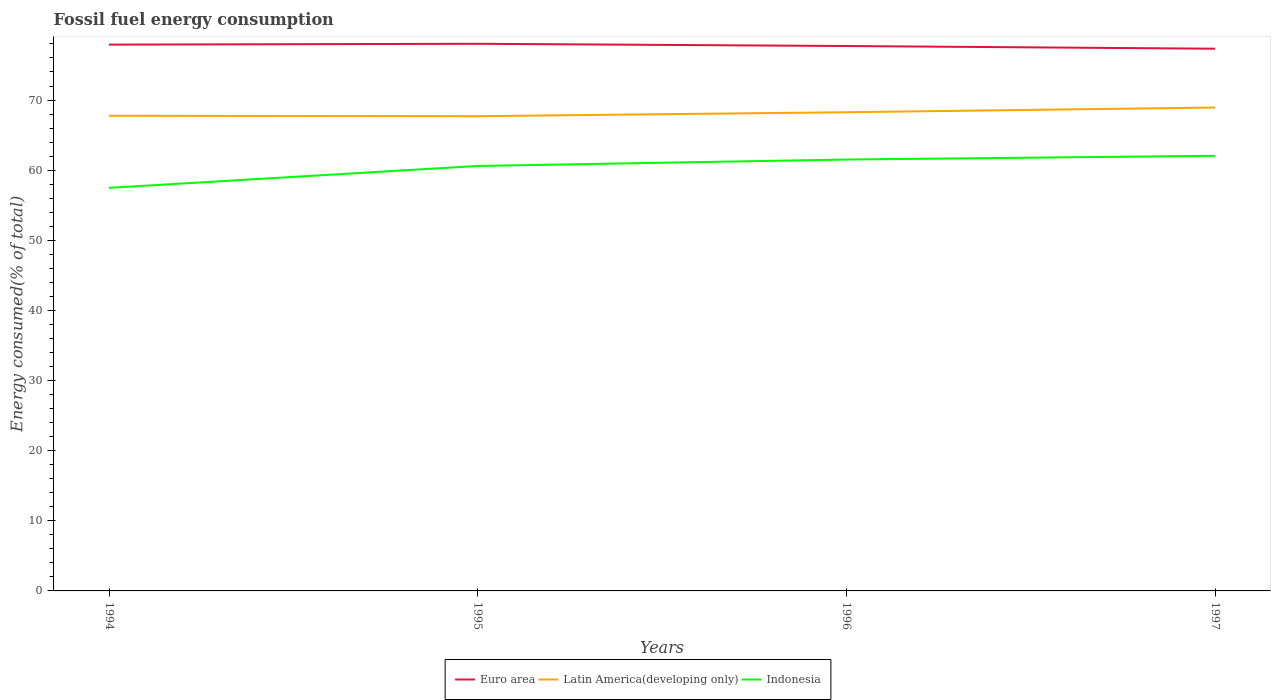Does the line corresponding to Latin America(developing only) intersect with the line corresponding to Indonesia?
Give a very brief answer. No. Across all years, what is the maximum percentage of energy consumed in Latin America(developing only)?
Provide a succinct answer. 67.7. In which year was the percentage of energy consumed in Latin America(developing only) maximum?
Make the answer very short. 1995. What is the total percentage of energy consumed in Indonesia in the graph?
Give a very brief answer. -0.53. What is the difference between the highest and the second highest percentage of energy consumed in Latin America(developing only)?
Offer a very short reply. 1.23. What is the difference between the highest and the lowest percentage of energy consumed in Latin America(developing only)?
Offer a terse response. 2. Is the percentage of energy consumed in Latin America(developing only) strictly greater than the percentage of energy consumed in Euro area over the years?
Provide a short and direct response. Yes. How many lines are there?
Your answer should be very brief. 3. Does the graph contain grids?
Your response must be concise. No. Where does the legend appear in the graph?
Offer a very short reply. Bottom center. How many legend labels are there?
Your answer should be compact. 3. How are the legend labels stacked?
Offer a terse response. Horizontal. What is the title of the graph?
Provide a short and direct response. Fossil fuel energy consumption. What is the label or title of the X-axis?
Your response must be concise. Years. What is the label or title of the Y-axis?
Keep it short and to the point. Energy consumed(% of total). What is the Energy consumed(% of total) of Euro area in 1994?
Make the answer very short. 77.9. What is the Energy consumed(% of total) in Latin America(developing only) in 1994?
Make the answer very short. 67.76. What is the Energy consumed(% of total) in Indonesia in 1994?
Give a very brief answer. 57.48. What is the Energy consumed(% of total) of Euro area in 1995?
Ensure brevity in your answer.  78.02. What is the Energy consumed(% of total) in Latin America(developing only) in 1995?
Your answer should be very brief. 67.7. What is the Energy consumed(% of total) in Indonesia in 1995?
Give a very brief answer. 60.6. What is the Energy consumed(% of total) of Euro area in 1996?
Your response must be concise. 77.7. What is the Energy consumed(% of total) of Latin America(developing only) in 1996?
Offer a terse response. 68.26. What is the Energy consumed(% of total) in Indonesia in 1996?
Your answer should be very brief. 61.51. What is the Energy consumed(% of total) in Euro area in 1997?
Make the answer very short. 77.32. What is the Energy consumed(% of total) of Latin America(developing only) in 1997?
Offer a very short reply. 68.93. What is the Energy consumed(% of total) of Indonesia in 1997?
Keep it short and to the point. 62.05. Across all years, what is the maximum Energy consumed(% of total) of Euro area?
Ensure brevity in your answer.  78.02. Across all years, what is the maximum Energy consumed(% of total) of Latin America(developing only)?
Offer a very short reply. 68.93. Across all years, what is the maximum Energy consumed(% of total) of Indonesia?
Offer a terse response. 62.05. Across all years, what is the minimum Energy consumed(% of total) in Euro area?
Offer a very short reply. 77.32. Across all years, what is the minimum Energy consumed(% of total) in Latin America(developing only)?
Give a very brief answer. 67.7. Across all years, what is the minimum Energy consumed(% of total) of Indonesia?
Ensure brevity in your answer.  57.48. What is the total Energy consumed(% of total) in Euro area in the graph?
Offer a very short reply. 310.95. What is the total Energy consumed(% of total) of Latin America(developing only) in the graph?
Keep it short and to the point. 272.64. What is the total Energy consumed(% of total) of Indonesia in the graph?
Ensure brevity in your answer.  241.64. What is the difference between the Energy consumed(% of total) in Euro area in 1994 and that in 1995?
Offer a very short reply. -0.12. What is the difference between the Energy consumed(% of total) of Latin America(developing only) in 1994 and that in 1995?
Give a very brief answer. 0.06. What is the difference between the Energy consumed(% of total) in Indonesia in 1994 and that in 1995?
Offer a terse response. -3.12. What is the difference between the Energy consumed(% of total) of Euro area in 1994 and that in 1996?
Ensure brevity in your answer.  0.2. What is the difference between the Energy consumed(% of total) of Latin America(developing only) in 1994 and that in 1996?
Your response must be concise. -0.5. What is the difference between the Energy consumed(% of total) of Indonesia in 1994 and that in 1996?
Provide a short and direct response. -4.04. What is the difference between the Energy consumed(% of total) in Euro area in 1994 and that in 1997?
Make the answer very short. 0.58. What is the difference between the Energy consumed(% of total) of Latin America(developing only) in 1994 and that in 1997?
Provide a succinct answer. -1.18. What is the difference between the Energy consumed(% of total) in Indonesia in 1994 and that in 1997?
Give a very brief answer. -4.57. What is the difference between the Energy consumed(% of total) of Euro area in 1995 and that in 1996?
Your answer should be very brief. 0.32. What is the difference between the Energy consumed(% of total) in Latin America(developing only) in 1995 and that in 1996?
Give a very brief answer. -0.56. What is the difference between the Energy consumed(% of total) of Indonesia in 1995 and that in 1996?
Offer a very short reply. -0.92. What is the difference between the Energy consumed(% of total) of Euro area in 1995 and that in 1997?
Make the answer very short. 0.7. What is the difference between the Energy consumed(% of total) in Latin America(developing only) in 1995 and that in 1997?
Give a very brief answer. -1.23. What is the difference between the Energy consumed(% of total) in Indonesia in 1995 and that in 1997?
Make the answer very short. -1.45. What is the difference between the Energy consumed(% of total) in Euro area in 1996 and that in 1997?
Make the answer very short. 0.38. What is the difference between the Energy consumed(% of total) of Latin America(developing only) in 1996 and that in 1997?
Your response must be concise. -0.67. What is the difference between the Energy consumed(% of total) of Indonesia in 1996 and that in 1997?
Your answer should be compact. -0.53. What is the difference between the Energy consumed(% of total) in Euro area in 1994 and the Energy consumed(% of total) in Latin America(developing only) in 1995?
Make the answer very short. 10.2. What is the difference between the Energy consumed(% of total) of Euro area in 1994 and the Energy consumed(% of total) of Indonesia in 1995?
Your response must be concise. 17.3. What is the difference between the Energy consumed(% of total) of Latin America(developing only) in 1994 and the Energy consumed(% of total) of Indonesia in 1995?
Offer a terse response. 7.16. What is the difference between the Energy consumed(% of total) in Euro area in 1994 and the Energy consumed(% of total) in Latin America(developing only) in 1996?
Offer a very short reply. 9.64. What is the difference between the Energy consumed(% of total) in Euro area in 1994 and the Energy consumed(% of total) in Indonesia in 1996?
Provide a succinct answer. 16.39. What is the difference between the Energy consumed(% of total) in Latin America(developing only) in 1994 and the Energy consumed(% of total) in Indonesia in 1996?
Your answer should be very brief. 6.24. What is the difference between the Energy consumed(% of total) of Euro area in 1994 and the Energy consumed(% of total) of Latin America(developing only) in 1997?
Offer a terse response. 8.97. What is the difference between the Energy consumed(% of total) in Euro area in 1994 and the Energy consumed(% of total) in Indonesia in 1997?
Ensure brevity in your answer.  15.85. What is the difference between the Energy consumed(% of total) in Latin America(developing only) in 1994 and the Energy consumed(% of total) in Indonesia in 1997?
Offer a terse response. 5.71. What is the difference between the Energy consumed(% of total) in Euro area in 1995 and the Energy consumed(% of total) in Latin America(developing only) in 1996?
Your response must be concise. 9.76. What is the difference between the Energy consumed(% of total) of Euro area in 1995 and the Energy consumed(% of total) of Indonesia in 1996?
Make the answer very short. 16.51. What is the difference between the Energy consumed(% of total) in Latin America(developing only) in 1995 and the Energy consumed(% of total) in Indonesia in 1996?
Your answer should be very brief. 6.18. What is the difference between the Energy consumed(% of total) of Euro area in 1995 and the Energy consumed(% of total) of Latin America(developing only) in 1997?
Give a very brief answer. 9.09. What is the difference between the Energy consumed(% of total) in Euro area in 1995 and the Energy consumed(% of total) in Indonesia in 1997?
Provide a succinct answer. 15.97. What is the difference between the Energy consumed(% of total) in Latin America(developing only) in 1995 and the Energy consumed(% of total) in Indonesia in 1997?
Give a very brief answer. 5.65. What is the difference between the Energy consumed(% of total) of Euro area in 1996 and the Energy consumed(% of total) of Latin America(developing only) in 1997?
Offer a terse response. 8.77. What is the difference between the Energy consumed(% of total) in Euro area in 1996 and the Energy consumed(% of total) in Indonesia in 1997?
Offer a terse response. 15.65. What is the difference between the Energy consumed(% of total) in Latin America(developing only) in 1996 and the Energy consumed(% of total) in Indonesia in 1997?
Give a very brief answer. 6.21. What is the average Energy consumed(% of total) in Euro area per year?
Keep it short and to the point. 77.74. What is the average Energy consumed(% of total) in Latin America(developing only) per year?
Your answer should be very brief. 68.16. What is the average Energy consumed(% of total) in Indonesia per year?
Ensure brevity in your answer.  60.41. In the year 1994, what is the difference between the Energy consumed(% of total) of Euro area and Energy consumed(% of total) of Latin America(developing only)?
Give a very brief answer. 10.15. In the year 1994, what is the difference between the Energy consumed(% of total) of Euro area and Energy consumed(% of total) of Indonesia?
Offer a very short reply. 20.42. In the year 1994, what is the difference between the Energy consumed(% of total) of Latin America(developing only) and Energy consumed(% of total) of Indonesia?
Offer a very short reply. 10.28. In the year 1995, what is the difference between the Energy consumed(% of total) in Euro area and Energy consumed(% of total) in Latin America(developing only)?
Ensure brevity in your answer.  10.33. In the year 1995, what is the difference between the Energy consumed(% of total) in Euro area and Energy consumed(% of total) in Indonesia?
Provide a succinct answer. 17.42. In the year 1995, what is the difference between the Energy consumed(% of total) of Latin America(developing only) and Energy consumed(% of total) of Indonesia?
Provide a succinct answer. 7.1. In the year 1996, what is the difference between the Energy consumed(% of total) in Euro area and Energy consumed(% of total) in Latin America(developing only)?
Offer a terse response. 9.44. In the year 1996, what is the difference between the Energy consumed(% of total) of Euro area and Energy consumed(% of total) of Indonesia?
Your answer should be very brief. 16.19. In the year 1996, what is the difference between the Energy consumed(% of total) of Latin America(developing only) and Energy consumed(% of total) of Indonesia?
Give a very brief answer. 6.74. In the year 1997, what is the difference between the Energy consumed(% of total) of Euro area and Energy consumed(% of total) of Latin America(developing only)?
Make the answer very short. 8.39. In the year 1997, what is the difference between the Energy consumed(% of total) in Euro area and Energy consumed(% of total) in Indonesia?
Your response must be concise. 15.27. In the year 1997, what is the difference between the Energy consumed(% of total) in Latin America(developing only) and Energy consumed(% of total) in Indonesia?
Your answer should be compact. 6.88. What is the ratio of the Energy consumed(% of total) of Indonesia in 1994 to that in 1995?
Give a very brief answer. 0.95. What is the ratio of the Energy consumed(% of total) in Euro area in 1994 to that in 1996?
Ensure brevity in your answer.  1. What is the ratio of the Energy consumed(% of total) of Latin America(developing only) in 1994 to that in 1996?
Your response must be concise. 0.99. What is the ratio of the Energy consumed(% of total) of Indonesia in 1994 to that in 1996?
Your answer should be compact. 0.93. What is the ratio of the Energy consumed(% of total) in Euro area in 1994 to that in 1997?
Your answer should be compact. 1.01. What is the ratio of the Energy consumed(% of total) in Latin America(developing only) in 1994 to that in 1997?
Keep it short and to the point. 0.98. What is the ratio of the Energy consumed(% of total) in Indonesia in 1994 to that in 1997?
Your answer should be very brief. 0.93. What is the ratio of the Energy consumed(% of total) of Euro area in 1995 to that in 1996?
Offer a terse response. 1. What is the ratio of the Energy consumed(% of total) of Indonesia in 1995 to that in 1996?
Make the answer very short. 0.99. What is the ratio of the Energy consumed(% of total) in Euro area in 1995 to that in 1997?
Offer a terse response. 1.01. What is the ratio of the Energy consumed(% of total) of Latin America(developing only) in 1995 to that in 1997?
Keep it short and to the point. 0.98. What is the ratio of the Energy consumed(% of total) of Indonesia in 1995 to that in 1997?
Your answer should be compact. 0.98. What is the ratio of the Energy consumed(% of total) in Latin America(developing only) in 1996 to that in 1997?
Provide a succinct answer. 0.99. What is the difference between the highest and the second highest Energy consumed(% of total) in Euro area?
Your response must be concise. 0.12. What is the difference between the highest and the second highest Energy consumed(% of total) in Latin America(developing only)?
Provide a succinct answer. 0.67. What is the difference between the highest and the second highest Energy consumed(% of total) of Indonesia?
Your response must be concise. 0.53. What is the difference between the highest and the lowest Energy consumed(% of total) of Euro area?
Your answer should be very brief. 0.7. What is the difference between the highest and the lowest Energy consumed(% of total) in Latin America(developing only)?
Offer a very short reply. 1.23. What is the difference between the highest and the lowest Energy consumed(% of total) of Indonesia?
Provide a short and direct response. 4.57. 